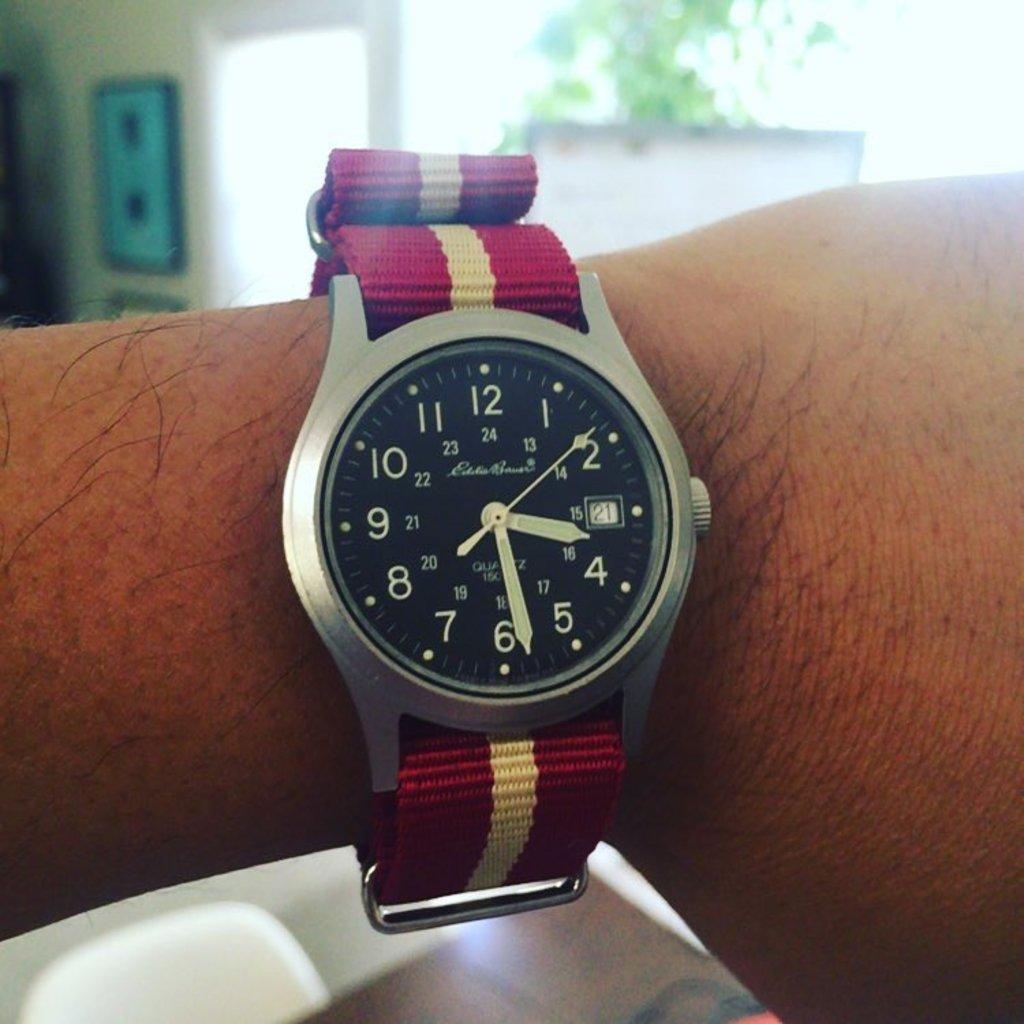What time is it?
Your answer should be very brief. 3:28. Who is the watch maker?
Provide a short and direct response. Eddie bauer. 